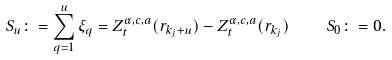Convert formula to latex. <formula><loc_0><loc_0><loc_500><loc_500>S _ { u } \colon = \sum _ { q = 1 } ^ { u } \xi _ { q } = Z _ { t } ^ { \alpha , c , a } ( r _ { k _ { j } + u } ) - Z _ { t } ^ { \alpha , c , a } ( r _ { k _ { j } } ) \quad S _ { 0 } \colon = 0 .</formula> 